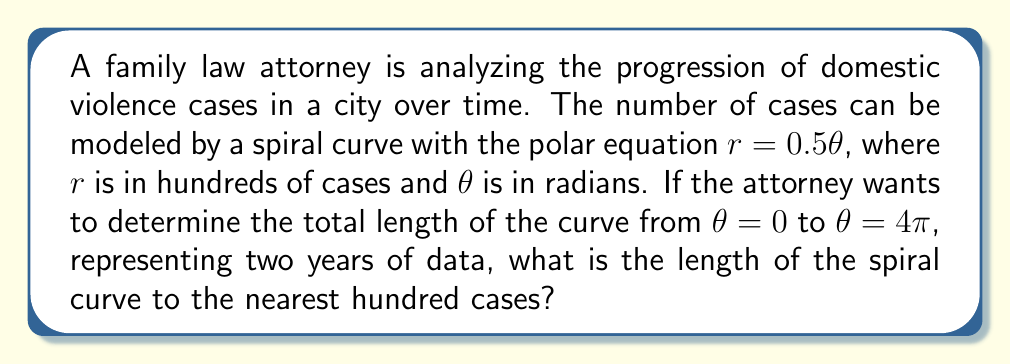Teach me how to tackle this problem. To solve this problem, we need to use the formula for the length of a curve in polar coordinates and then integrate it. The steps are as follows:

1) The formula for the length of a curve in polar coordinates is:

   $$L = \int_a^b \sqrt{r^2 + \left(\frac{dr}{d\theta}\right)^2} d\theta$$

2) We're given $r = 0.5\theta$. We need to find $\frac{dr}{d\theta}$:

   $$\frac{dr}{d\theta} = 0.5$$

3) Now we can substitute these into our length formula:

   $$L = \int_0^{4\pi} \sqrt{(0.5\theta)^2 + (0.5)^2} d\theta$$

4) Simplify under the square root:

   $$L = \int_0^{4\pi} \sqrt{0.25\theta^2 + 0.25} d\theta$$

5) Factor out 0.25:

   $$L = \int_0^{4\pi} 0.5\sqrt{\theta^2 + 1} d\theta$$

6) This integral doesn't have an elementary antiderivative. We need to use the substitution $\theta = \sinh u$ to solve it:

   $$L = 0.5 \int_0^{\sinh^{-1}(4\pi)} \sqrt{\sinh^2 u + 1} \cosh u du$$

7) Simplify using the identity $\sinh^2 u + 1 = \cosh^2 u$:

   $$L = 0.5 \int_0^{\sinh^{-1}(4\pi)} \cosh^2 u du$$

8) The integral of $\cosh^2 u$ is $\frac{1}{4}(2u + \sinh(2u))$, so:

   $$L = 0.5 \left[\frac{1}{4}(2u + \sinh(2u))\right]_0^{\sinh^{-1}(4\pi)}$$

9) Evaluate:

   $$L = 0.5 \left[\frac{1}{2}\sinh^{-1}(4\pi) + \frac{1}{4}\sinh(2\sinh^{-1}(4\pi))\right]$$

10) Simplify using $\sinh(2\sinh^{-1}(x)) = 2x\sqrt{1+x^2}$:

    $$L = 0.5 \left[\frac{1}{2}\sinh^{-1}(4\pi) + \frac{1}{2}4\pi\sqrt{1+(4\pi)^2}\right]$$

11) Calculate the numeric value:

    $$L \approx 25.13$$

12) Remember that $r$ was in hundreds of cases, so multiply by 100:

    $$L \approx 2513$$ cases
Answer: 2500 cases (to the nearest hundred) 